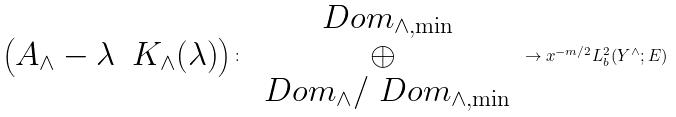Convert formula to latex. <formula><loc_0><loc_0><loc_500><loc_500>\begin{pmatrix} A _ { \wedge } - \lambda & K _ { \wedge } ( \lambda ) \end{pmatrix} \colon \begin{array} { c } \ D o m _ { \wedge , \min } \\ \oplus \\ \ D o m _ { \wedge } / \ D o m _ { \wedge , \min } \end{array} \to x ^ { - m / 2 } L ^ { 2 } _ { b } ( Y ^ { \wedge } ; E )</formula> 